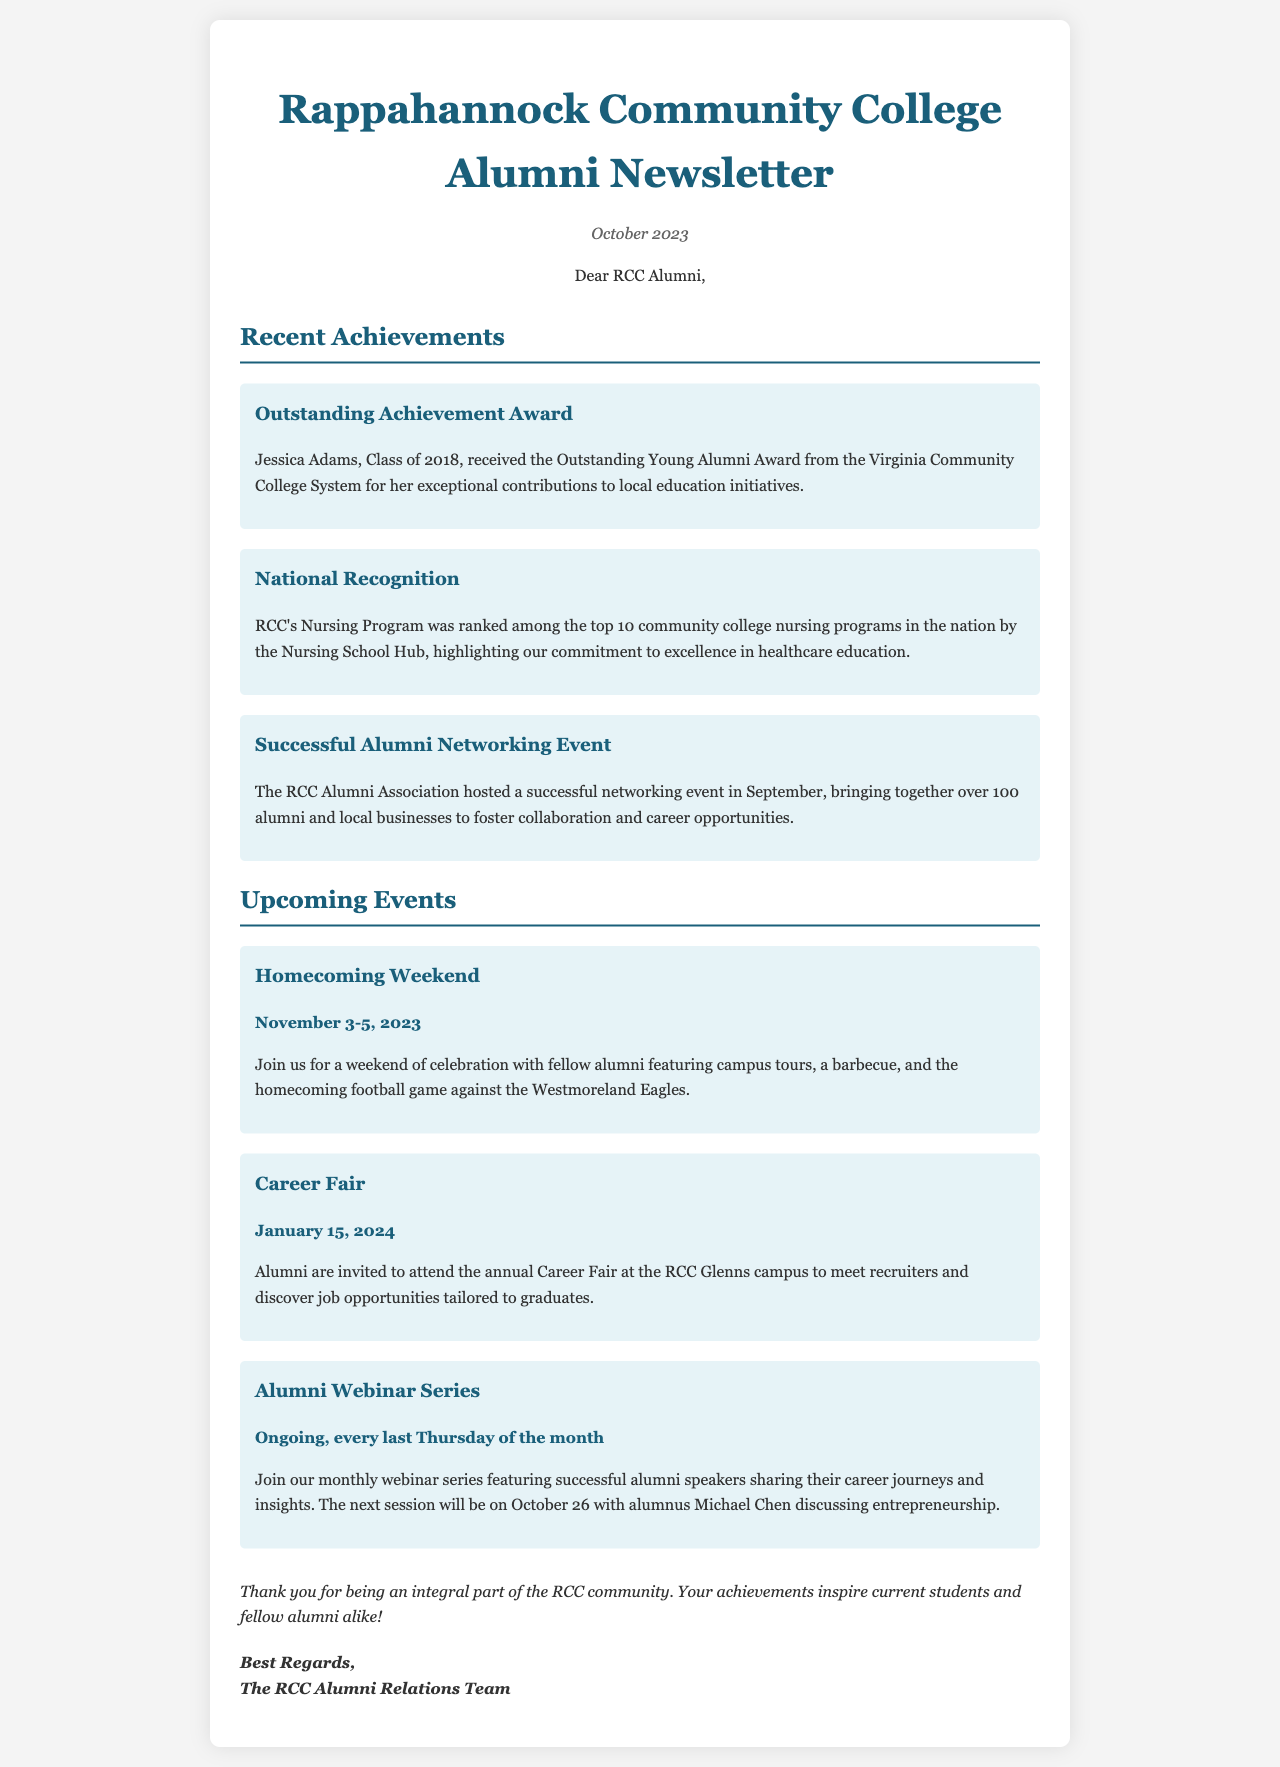What award did Jessica Adams receive? Jessica Adams received the Outstanding Young Alumni Award from the Virginia Community College System.
Answer: Outstanding Young Alumni Award What was RCC's Nursing Program ranked among? RCC's Nursing Program was ranked among the top 10 community college nursing programs in the nation.
Answer: Top 10 community college nursing programs When is Homecoming Weekend scheduled? Homecoming Weekend is scheduled for November 3-5, 2023.
Answer: November 3-5, 2023 What event features alumnus Michael Chen? The event featuring alumnus Michael Chen is part of the Alumni Webinar Series.
Answer: Alumni Webinar Series How many alumni attended the successful networking event? Over 100 alumni attended the successful networking event.
Answer: Over 100 alumni What type of event is the Career Fair? The Career Fair is an annual event for alumni to meet recruiters.
Answer: Annual event What date does the Alumni Webinar Series occur? The Alumni Webinar Series occurs every last Thursday of the month.
Answer: Every last Thursday of the month 